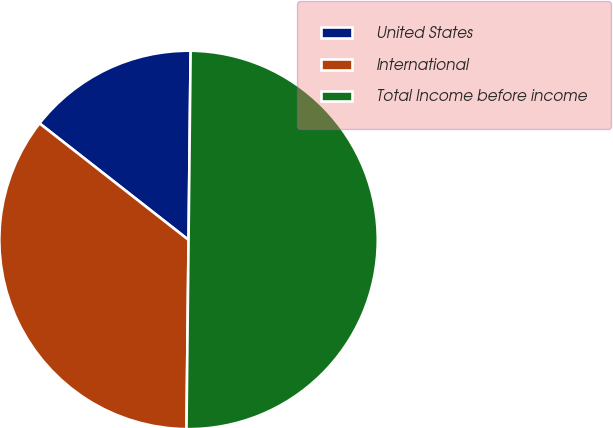Convert chart. <chart><loc_0><loc_0><loc_500><loc_500><pie_chart><fcel>United States<fcel>International<fcel>Total Income before income<nl><fcel>14.61%<fcel>35.39%<fcel>50.0%<nl></chart> 